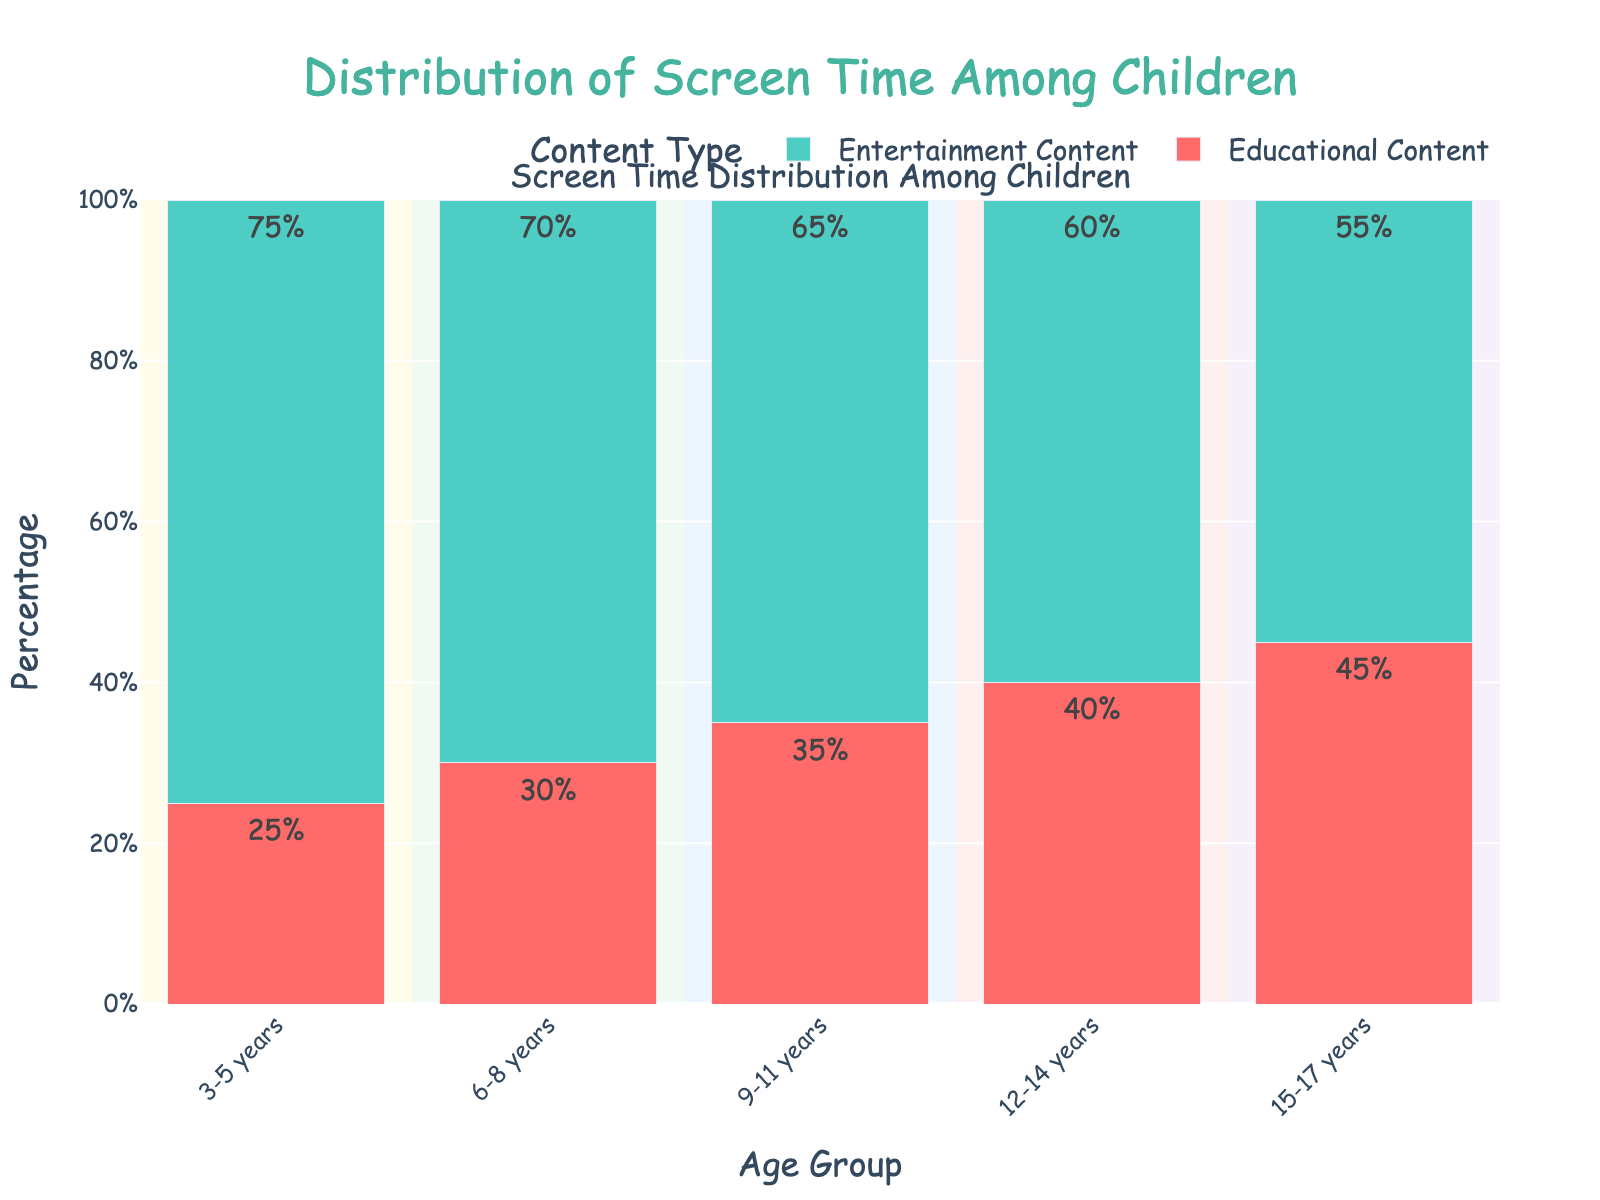Which age group spends the highest percentage of time on educational content? Look at the educational content percentage for each age group. The group with the highest percentage is the oldest one, 15-17 years, which stands at 45%.
Answer: 15-17 years Which type of content do 9-11-year-olds spend more time on? Compare the percentages of educational content (35%) and entertainment content (65%) for 9-11 years. Entertainment content has a higher percentage.
Answer: Entertainment content How does the percentage of educational content change from the 3-5 years group to the 15-17 years group? Calculate the difference between the educational content percentages of 15-17 years (45%) and 3-5 years (25%). 45% - 25% = 20%.
Answer: Increases by 20% What is the total screen time percentage spent on entertainment content by children aged 6-8 and 12-14 years combined? Add the entertainment content percentages for the 6-8 years (70%) and 12-14 years (60%). 70% + 60% = 130%.
Answer: 130% Which age group shows a 10% increase in educational content compared to the previous group? Check the educational content percentage for each group. The 12-14 years group has 40%, which is 10% more than the 9-11 years group's 30%.
Answer: 12-14 years Who spends less time on entertainment content: 3-5-year-olds or 15-17-year-olds? Compare the entertainment content percentages for 3-5 years (75%) and 15-17 years (55%). The older group spends less time.
Answer: 15-17-year-olds Is the difference in entertainment content percentage between 3-5 years and 6-8 years less than, equal to, or greater than 5%? Calculate the difference: 75% (3-5 years) - 70% (6-8 years) = 5%. It is equal to 5%.
Answer: Equal to 5% Which content type is most popular across all age groups? Check the visual heights of the bars and see that the Entertainment Content consistently has higher percentages across all age groups.
Answer: Entertainment content 